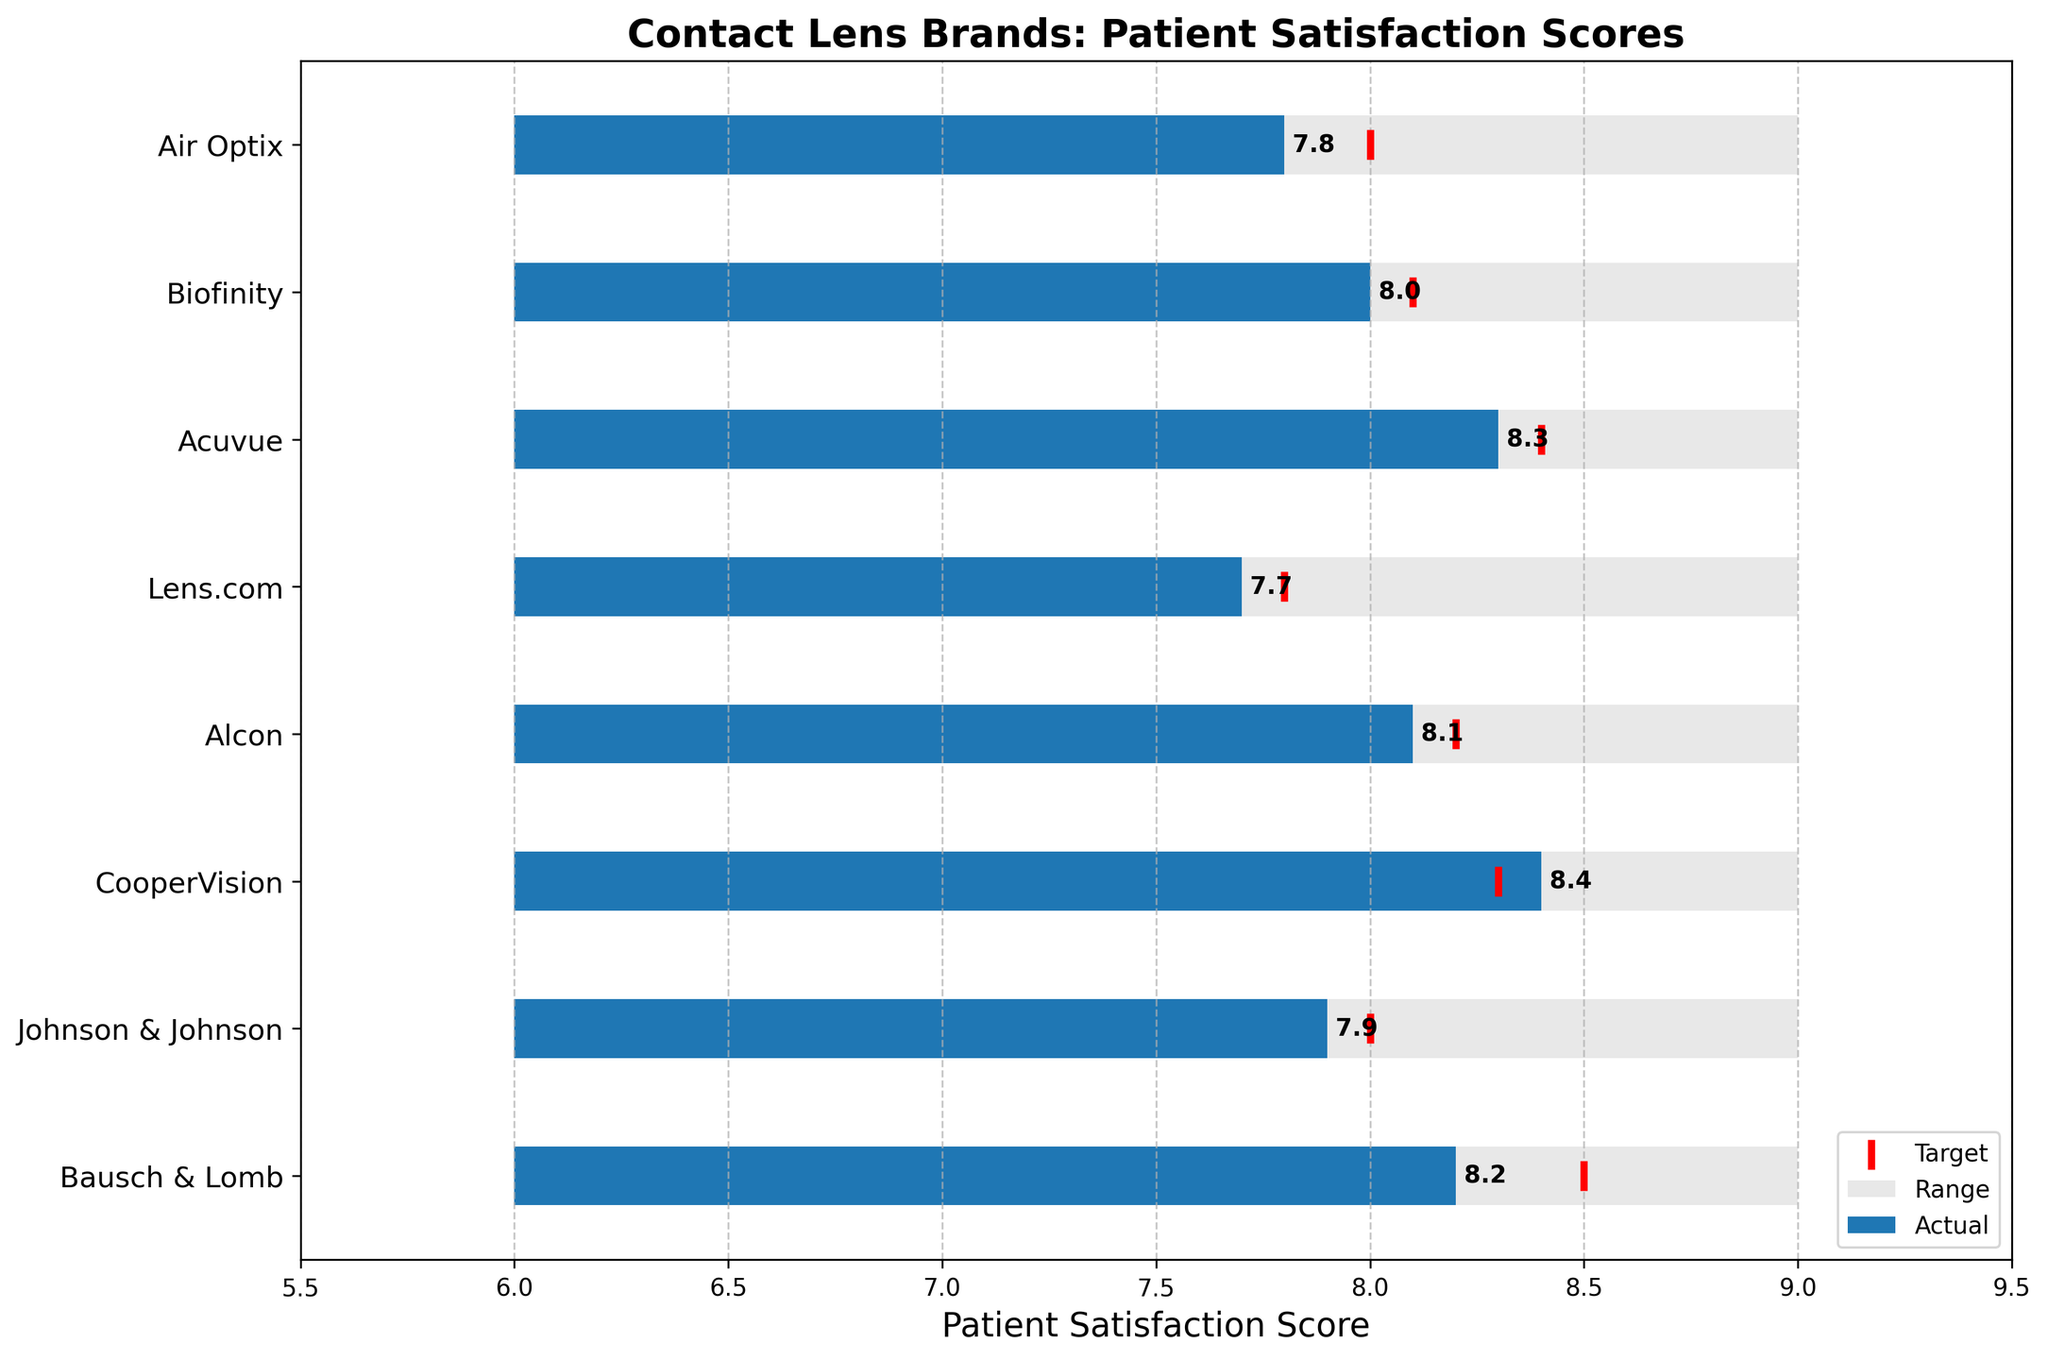What is the title of the chart? The title of the chart is usually positioned at the top and is prominently displayed to give an overview of the chart content. Here, it reads "Contact Lens Brands: Patient Satisfaction Scores."
Answer: Contact Lens Brands: Patient Satisfaction Scores Which contact lens brand has the highest actual patient satisfaction score? Looking at the blue bars representing the actual scores, CooperVision has the highest score of 8.4.
Answer: CooperVision How does Bausch & Lomb's actual score compare to its target score? Refer to the blue bar and the red target marker for Bausch & Lomb. Its actual score is 8.2, which is slightly less than its target score of 8.5.
Answer: Below What are the brands that met or exceeded their target satisfaction scores? Compare the blue bars and red target markers for each brand. CooperVision (8.4), Acuvue (8.3), and Alcon (8.1) met or exceeded their targets of 8.3, 8.4, and 8.2 respectively.
Answer: CooperVision, Acuvue, Alcon Between Johnson & Johnson and Air Optix, which brand has a closer actual score to its target? Calculate the differences for both brands. Johnson & Johnson has a difference of 0.1 (8.0 - 7.9), and Air Optix has a difference of 0.2 (8.0 - 7.8). Thus, Johnson & Johnson is closer to its target.
Answer: Johnson & Johnson What is the range of patient satisfaction scores for all brands? The grey bars represent the range starting from 6 to 9 across all brands.
Answer: 6 to 9 Which brand has the lowest target satisfaction score, and what is that score? By reviewing the red target markers, Lens.com has the lowest target score of 7.8.
Answer: Lens.com, 7.8 What is the difference between the highest actual satisfaction score and the lowest actual satisfaction score? The highest actual satisfaction score is 8.4 (CooperVision) and the lowest is 7.7 (Lens.com). The difference is 8.4 - 7.7 = 0.7.
Answer: 0.7 How many brands have actual scores that are within the range but below their target scores? Examine brands where the blue bars are within the grey range but below their red target markers: Bausch & Lomb, Johnson & Johnson, and Biofinity.
Answer: 3 brands What is the average target satisfaction score for all brands? Sum all target scores (8.5 + 8.0 + 8.3 + 8.2 + 7.8 + 8.4 + 8.1 + 8.0) = 65.3 and divide by the number of brands (8). The average is 65.3 / 8 = 8.163.
Answer: 8.163 